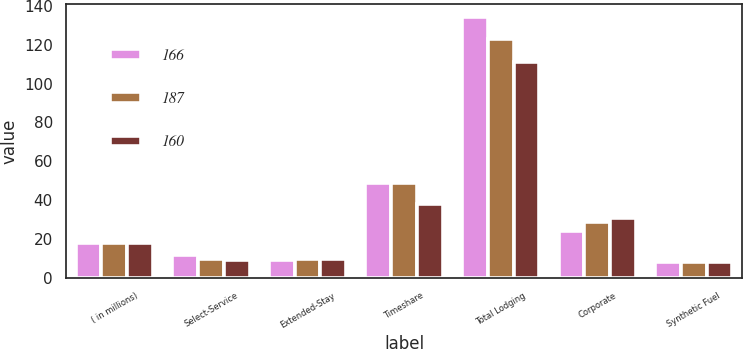Convert chart to OTSL. <chart><loc_0><loc_0><loc_500><loc_500><stacked_bar_chart><ecel><fcel>( in millions)<fcel>Select-Service<fcel>Extended-Stay<fcel>Timeshare<fcel>Total Lodging<fcel>Corporate<fcel>Synthetic Fuel<nl><fcel>166<fcel>18<fcel>12<fcel>9<fcel>49<fcel>134<fcel>24<fcel>8<nl><fcel>187<fcel>18<fcel>10<fcel>10<fcel>49<fcel>123<fcel>29<fcel>8<nl><fcel>160<fcel>18<fcel>9<fcel>10<fcel>38<fcel>111<fcel>31<fcel>8<nl></chart> 